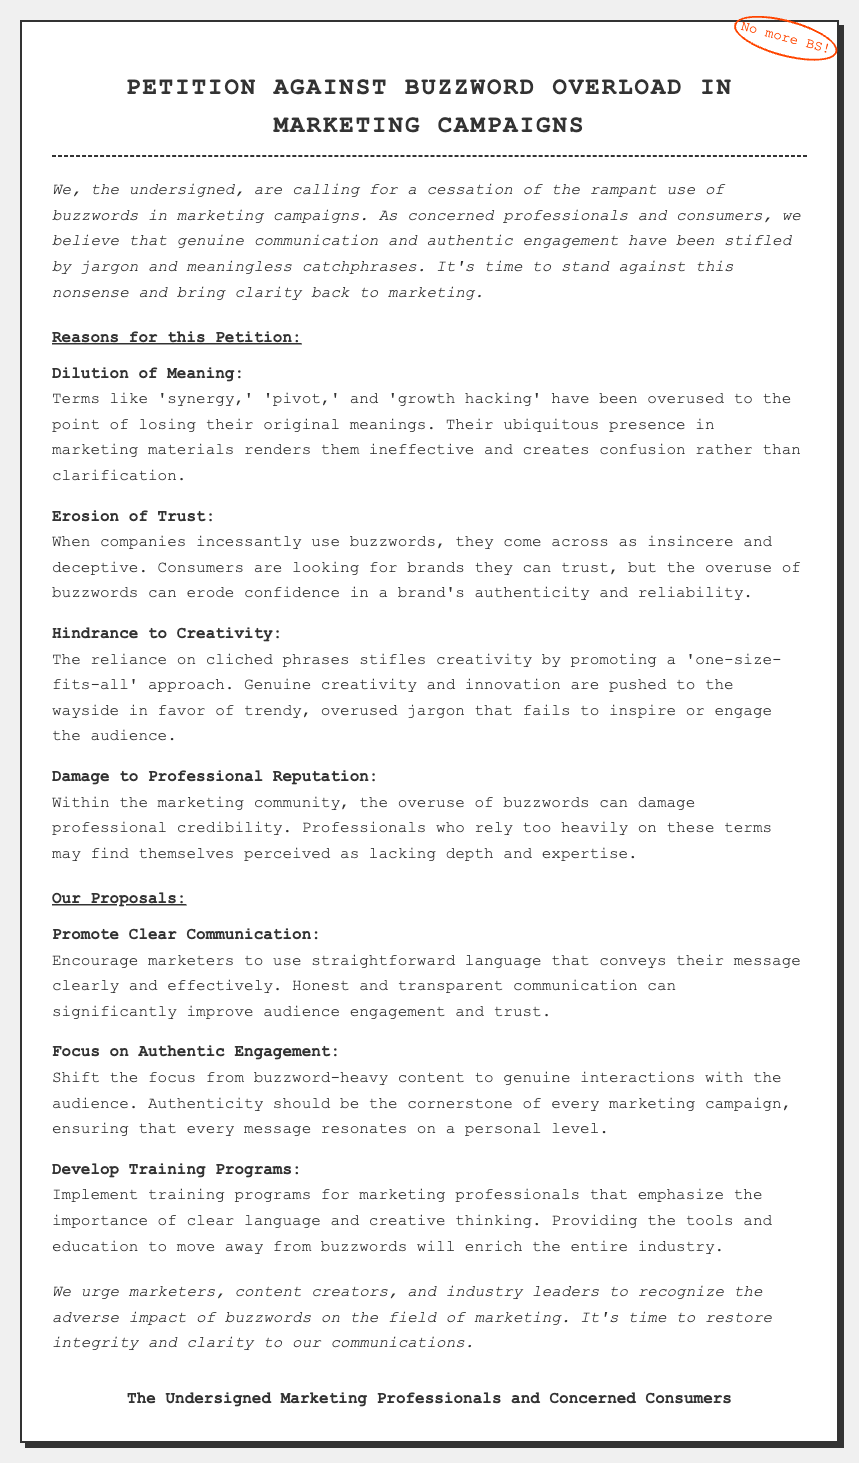What is the title of the petition? The title of the petition is prominently displayed at the top of the document.
Answer: Petition Against Buzzword Overload in Marketing Campaigns How many reasons are provided in the petition? The petition lists four distinct reasons for its request.
Answer: 4 What is the first reason stated in the petition? The first reason is listed under the section "Reasons for this Petition."
Answer: Dilution of Meaning What does the petition propose to promote? One of the proposals specifically addresses communication methods recommended.
Answer: Clear Communication Which profession is addressed for training programs in the proposals? Training programs are aimed specifically at a professional community mentioned in the document.
Answer: Marketing Professionals What effect do buzzwords have according to the document? The document outlines the negative impact of buzzwords on trust and communication.
Answer: Erosion of Trust What is the main complaint of consumers according to the petition? The primary complaint pertains to the style of communication used in marketing, as noted in the introduction.
Answer: Insincerity Who are the signatories of the petition? The document includes a section identifying those supporting the petition.
Answer: Marketing Professionals and Concerned Consumers 